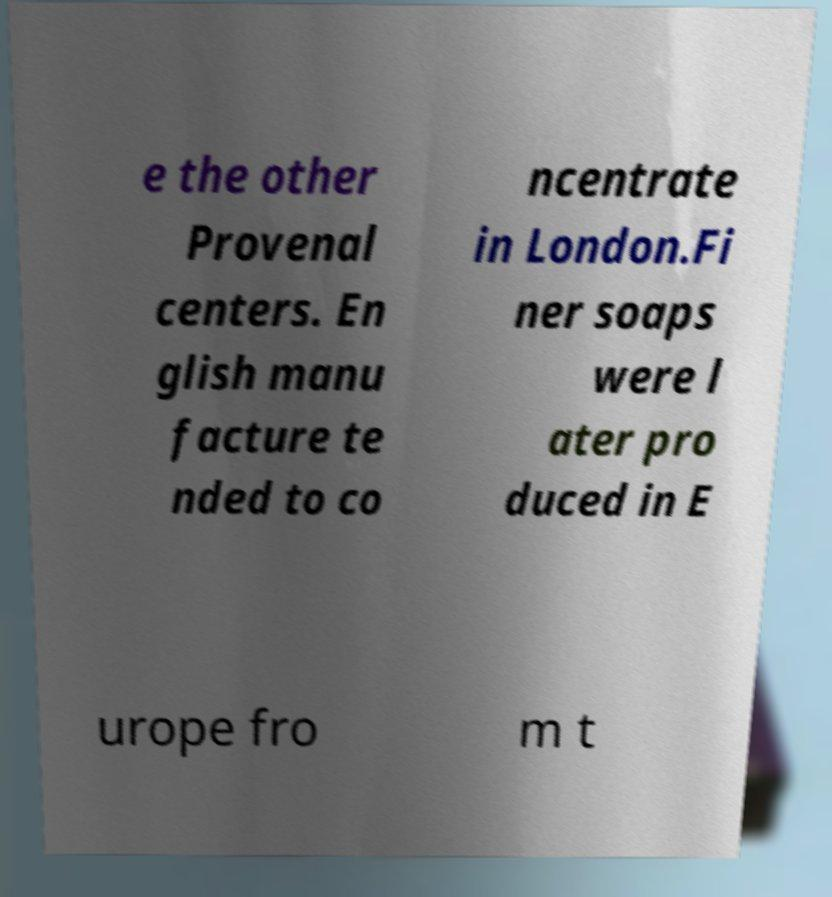There's text embedded in this image that I need extracted. Can you transcribe it verbatim? e the other Provenal centers. En glish manu facture te nded to co ncentrate in London.Fi ner soaps were l ater pro duced in E urope fro m t 